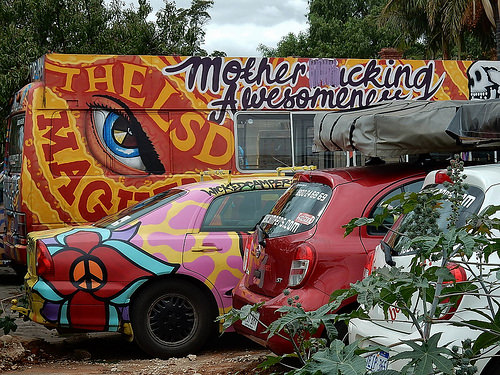<image>
Is there a car behind the plant? Yes. From this viewpoint, the car is positioned behind the plant, with the plant partially or fully occluding the car. 